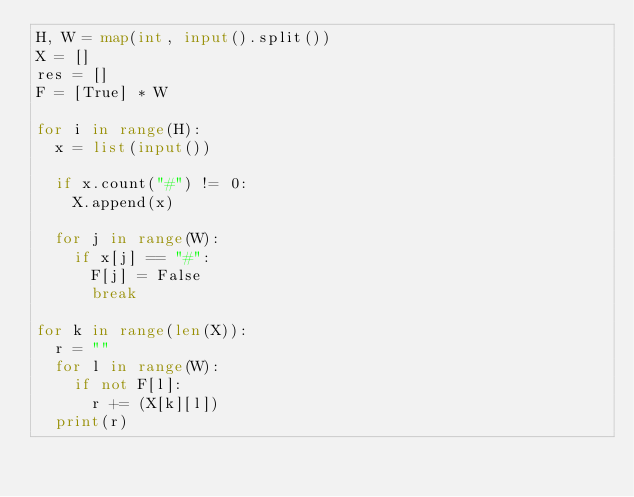<code> <loc_0><loc_0><loc_500><loc_500><_Python_>H, W = map(int, input().split())
X = []
res = []
F = [True] * W

for i in range(H):
  x = list(input())
   
  if x.count("#") != 0:
    X.append(x)

  for j in range(W):
    if x[j] == "#":
      F[j] = False
      break

for k in range(len(X)):
  r = ""
  for l in range(W):
    if not F[l]:
      r += (X[k][l])
  print(r)</code> 